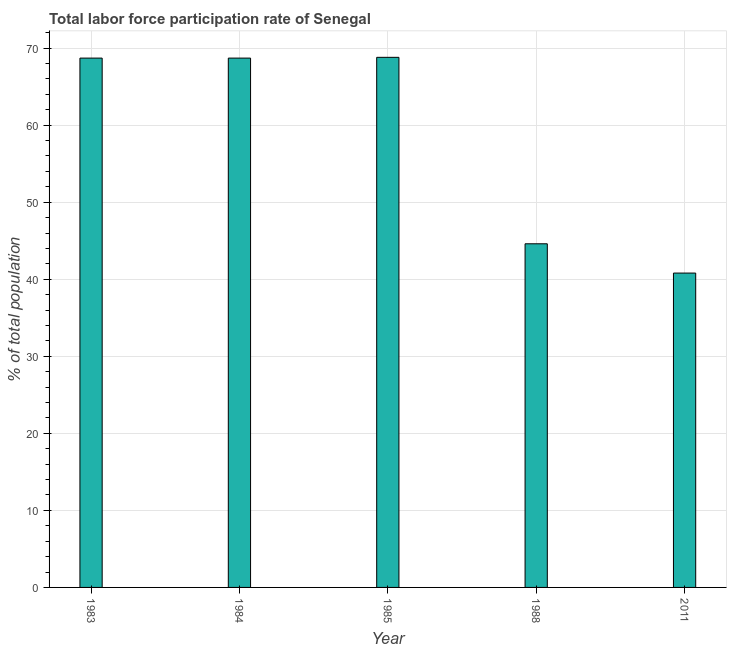Does the graph contain any zero values?
Provide a succinct answer. No. What is the title of the graph?
Ensure brevity in your answer.  Total labor force participation rate of Senegal. What is the label or title of the Y-axis?
Your answer should be compact. % of total population. What is the total labor force participation rate in 1983?
Offer a terse response. 68.7. Across all years, what is the maximum total labor force participation rate?
Offer a very short reply. 68.8. Across all years, what is the minimum total labor force participation rate?
Your answer should be very brief. 40.8. In which year was the total labor force participation rate maximum?
Your answer should be compact. 1985. What is the sum of the total labor force participation rate?
Keep it short and to the point. 291.6. What is the difference between the total labor force participation rate in 1983 and 1988?
Make the answer very short. 24.1. What is the average total labor force participation rate per year?
Your answer should be very brief. 58.32. What is the median total labor force participation rate?
Your answer should be very brief. 68.7. Do a majority of the years between 2011 and 1983 (inclusive) have total labor force participation rate greater than 22 %?
Make the answer very short. Yes. What is the ratio of the total labor force participation rate in 1985 to that in 1988?
Offer a terse response. 1.54. Is the difference between the total labor force participation rate in 1985 and 2011 greater than the difference between any two years?
Your answer should be very brief. Yes. Is the sum of the total labor force participation rate in 1983 and 2011 greater than the maximum total labor force participation rate across all years?
Keep it short and to the point. Yes. What is the difference between the highest and the lowest total labor force participation rate?
Keep it short and to the point. 28. In how many years, is the total labor force participation rate greater than the average total labor force participation rate taken over all years?
Your response must be concise. 3. How many bars are there?
Keep it short and to the point. 5. Are all the bars in the graph horizontal?
Your answer should be very brief. No. How many years are there in the graph?
Your answer should be very brief. 5. Are the values on the major ticks of Y-axis written in scientific E-notation?
Make the answer very short. No. What is the % of total population of 1983?
Make the answer very short. 68.7. What is the % of total population of 1984?
Offer a very short reply. 68.7. What is the % of total population of 1985?
Offer a very short reply. 68.8. What is the % of total population in 1988?
Ensure brevity in your answer.  44.6. What is the % of total population in 2011?
Your response must be concise. 40.8. What is the difference between the % of total population in 1983 and 1985?
Give a very brief answer. -0.1. What is the difference between the % of total population in 1983 and 1988?
Offer a very short reply. 24.1. What is the difference between the % of total population in 1983 and 2011?
Your answer should be compact. 27.9. What is the difference between the % of total population in 1984 and 1985?
Keep it short and to the point. -0.1. What is the difference between the % of total population in 1984 and 1988?
Provide a succinct answer. 24.1. What is the difference between the % of total population in 1984 and 2011?
Offer a very short reply. 27.9. What is the difference between the % of total population in 1985 and 1988?
Offer a very short reply. 24.2. What is the difference between the % of total population in 1985 and 2011?
Keep it short and to the point. 28. What is the difference between the % of total population in 1988 and 2011?
Your answer should be compact. 3.8. What is the ratio of the % of total population in 1983 to that in 1988?
Ensure brevity in your answer.  1.54. What is the ratio of the % of total population in 1983 to that in 2011?
Provide a succinct answer. 1.68. What is the ratio of the % of total population in 1984 to that in 1985?
Offer a very short reply. 1. What is the ratio of the % of total population in 1984 to that in 1988?
Provide a succinct answer. 1.54. What is the ratio of the % of total population in 1984 to that in 2011?
Ensure brevity in your answer.  1.68. What is the ratio of the % of total population in 1985 to that in 1988?
Give a very brief answer. 1.54. What is the ratio of the % of total population in 1985 to that in 2011?
Make the answer very short. 1.69. What is the ratio of the % of total population in 1988 to that in 2011?
Provide a short and direct response. 1.09. 